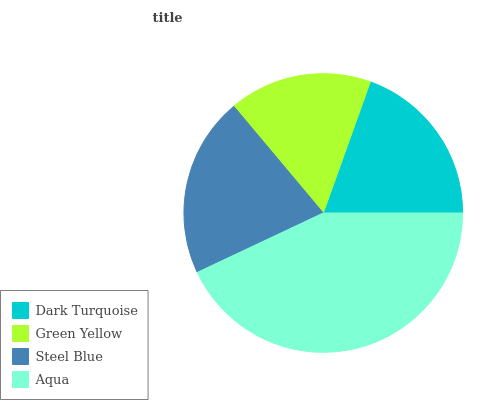Is Green Yellow the minimum?
Answer yes or no. Yes. Is Aqua the maximum?
Answer yes or no. Yes. Is Steel Blue the minimum?
Answer yes or no. No. Is Steel Blue the maximum?
Answer yes or no. No. Is Steel Blue greater than Green Yellow?
Answer yes or no. Yes. Is Green Yellow less than Steel Blue?
Answer yes or no. Yes. Is Green Yellow greater than Steel Blue?
Answer yes or no. No. Is Steel Blue less than Green Yellow?
Answer yes or no. No. Is Steel Blue the high median?
Answer yes or no. Yes. Is Dark Turquoise the low median?
Answer yes or no. Yes. Is Green Yellow the high median?
Answer yes or no. No. Is Aqua the low median?
Answer yes or no. No. 